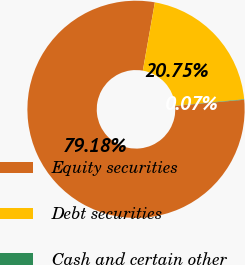<chart> <loc_0><loc_0><loc_500><loc_500><pie_chart><fcel>Equity securities<fcel>Debt securities<fcel>Cash and certain other<nl><fcel>79.18%<fcel>20.75%<fcel>0.07%<nl></chart> 